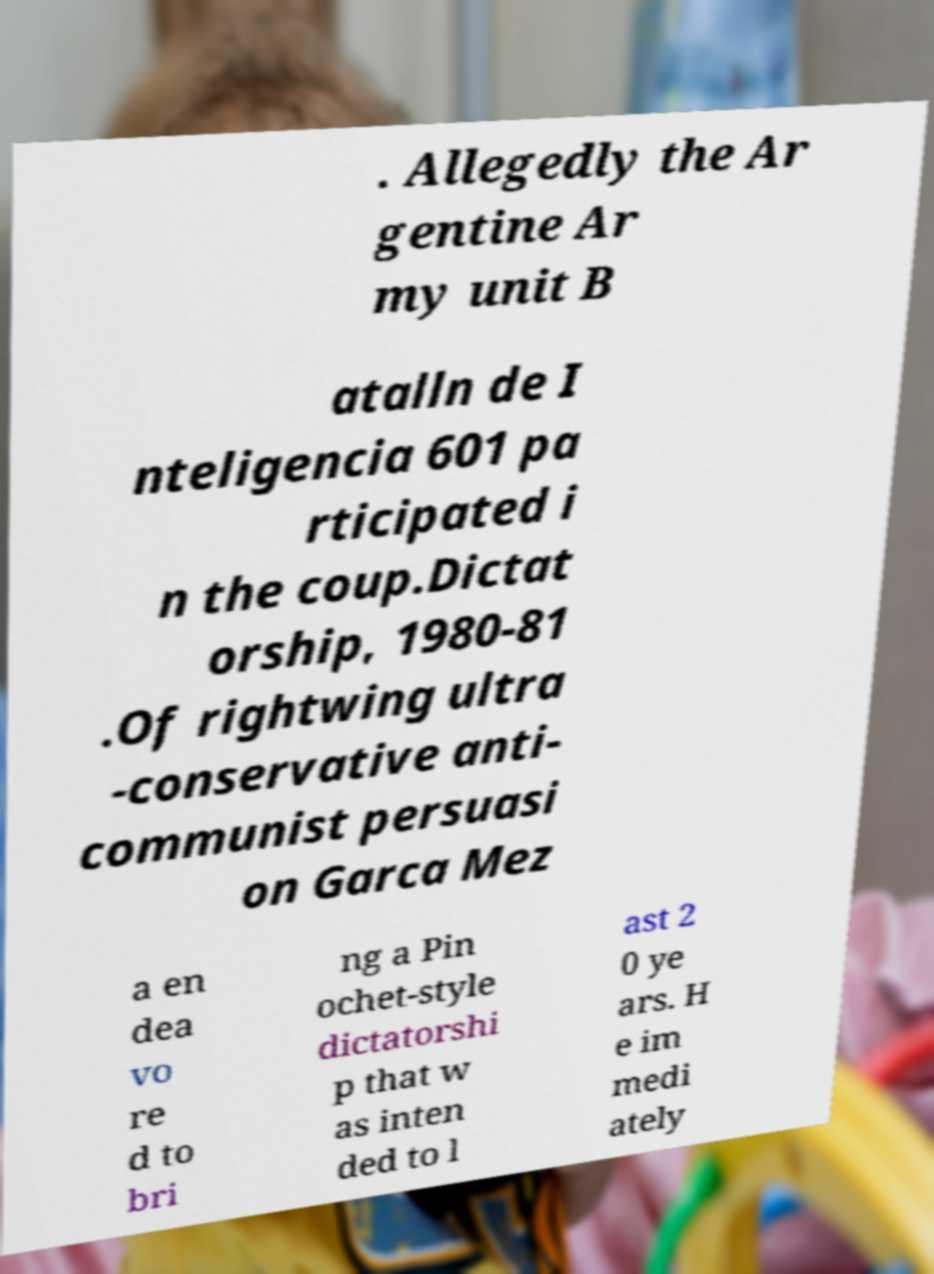Can you read and provide the text displayed in the image?This photo seems to have some interesting text. Can you extract and type it out for me? . Allegedly the Ar gentine Ar my unit B atalln de I nteligencia 601 pa rticipated i n the coup.Dictat orship, 1980-81 .Of rightwing ultra -conservative anti- communist persuasi on Garca Mez a en dea vo re d to bri ng a Pin ochet-style dictatorshi p that w as inten ded to l ast 2 0 ye ars. H e im medi ately 